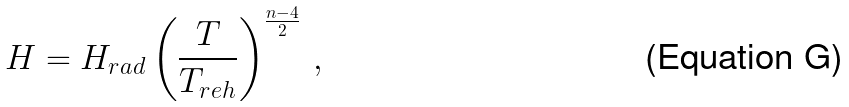<formula> <loc_0><loc_0><loc_500><loc_500>H = H _ { r a d } \left ( \frac { T } { T _ { r e h } } \right ) ^ { \frac { n - 4 } { 2 } } \, ,</formula> 